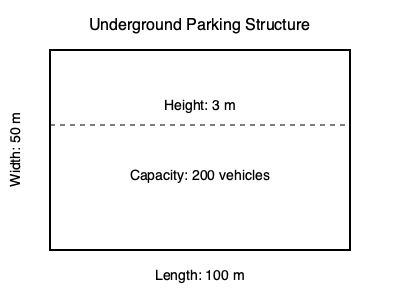Calculate the required ventilation rate in cubic meters per second (m³/s) for the underground parking structure shown in the diagram. Assume the ventilation requirement is 6 air changes per hour and that 75% of the parking spaces are occupied during peak hours. To calculate the required ventilation rate, we'll follow these steps:

1. Calculate the volume of the parking structure:
   Volume = Length × Width × Height
   $V = 100 \text{ m} \times 50 \text{ m} \times 3 \text{ m} = 15,000 \text{ m}^3$

2. Determine the required air changes per hour:
   Given: 6 air changes per hour

3. Calculate the total air volume to be changed per hour:
   $\text{Air volume per hour} = 6 \times 15,000 \text{ m}^3 = 90,000 \text{ m}^3/\text{hour}$

4. Convert the air volume per hour to cubic meters per second:
   $\text{Ventilation rate} = \frac{90,000 \text{ m}^3/\text{hour}}{3600 \text{ s/hour}} = 25 \text{ m}^3/\text{s}$

5. Adjust for occupancy:
   Given: 75% occupancy during peak hours
   $\text{Adjusted ventilation rate} = 25 \text{ m}^3/\text{s} \times 0.75 = 18.75 \text{ m}^3/\text{s}$

Therefore, the required ventilation rate for the underground parking structure is 18.75 m³/s.
Answer: 18.75 m³/s 